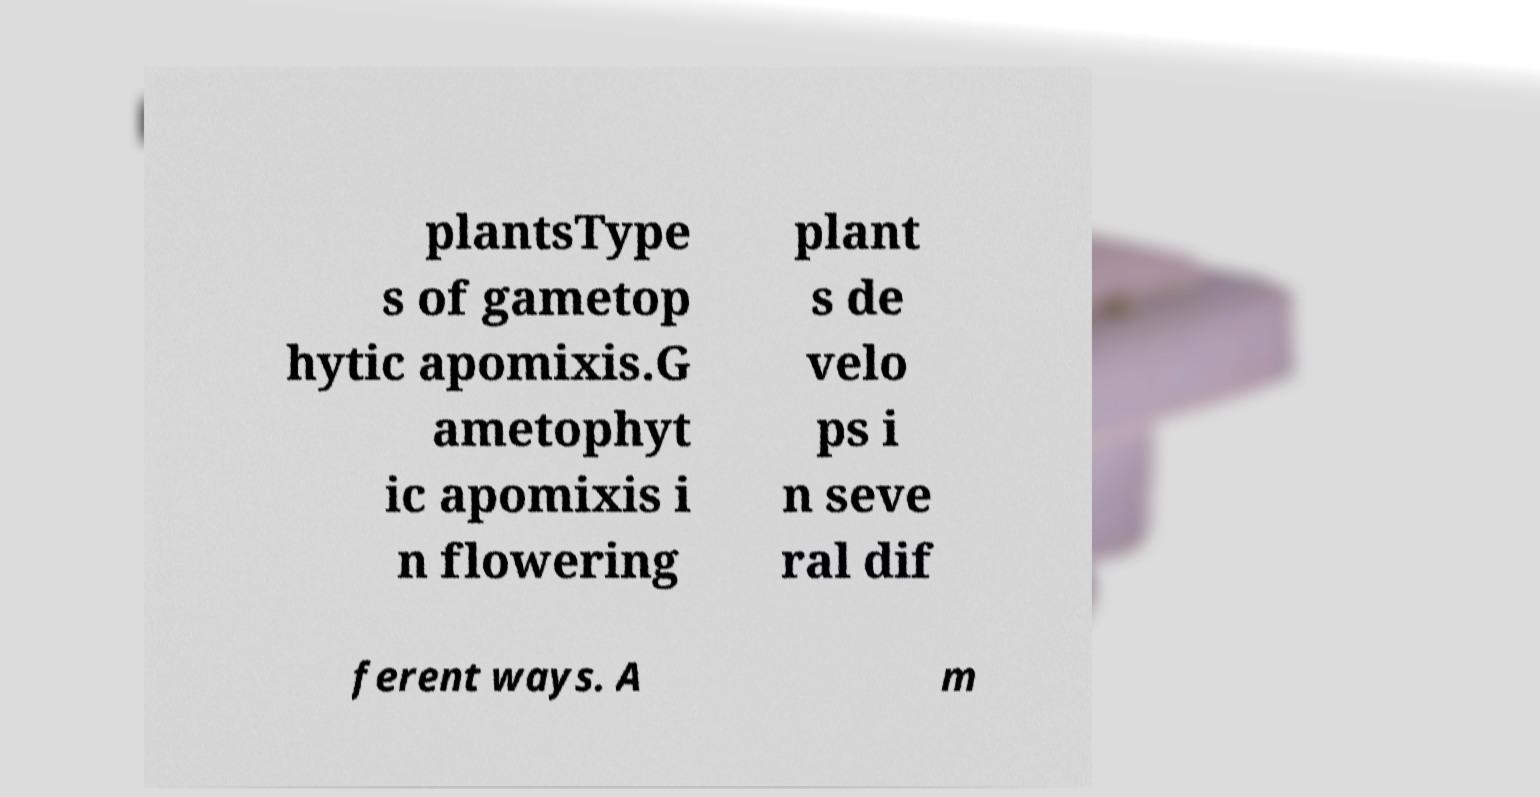There's text embedded in this image that I need extracted. Can you transcribe it verbatim? plantsType s of gametop hytic apomixis.G ametophyt ic apomixis i n flowering plant s de velo ps i n seve ral dif ferent ways. A m 